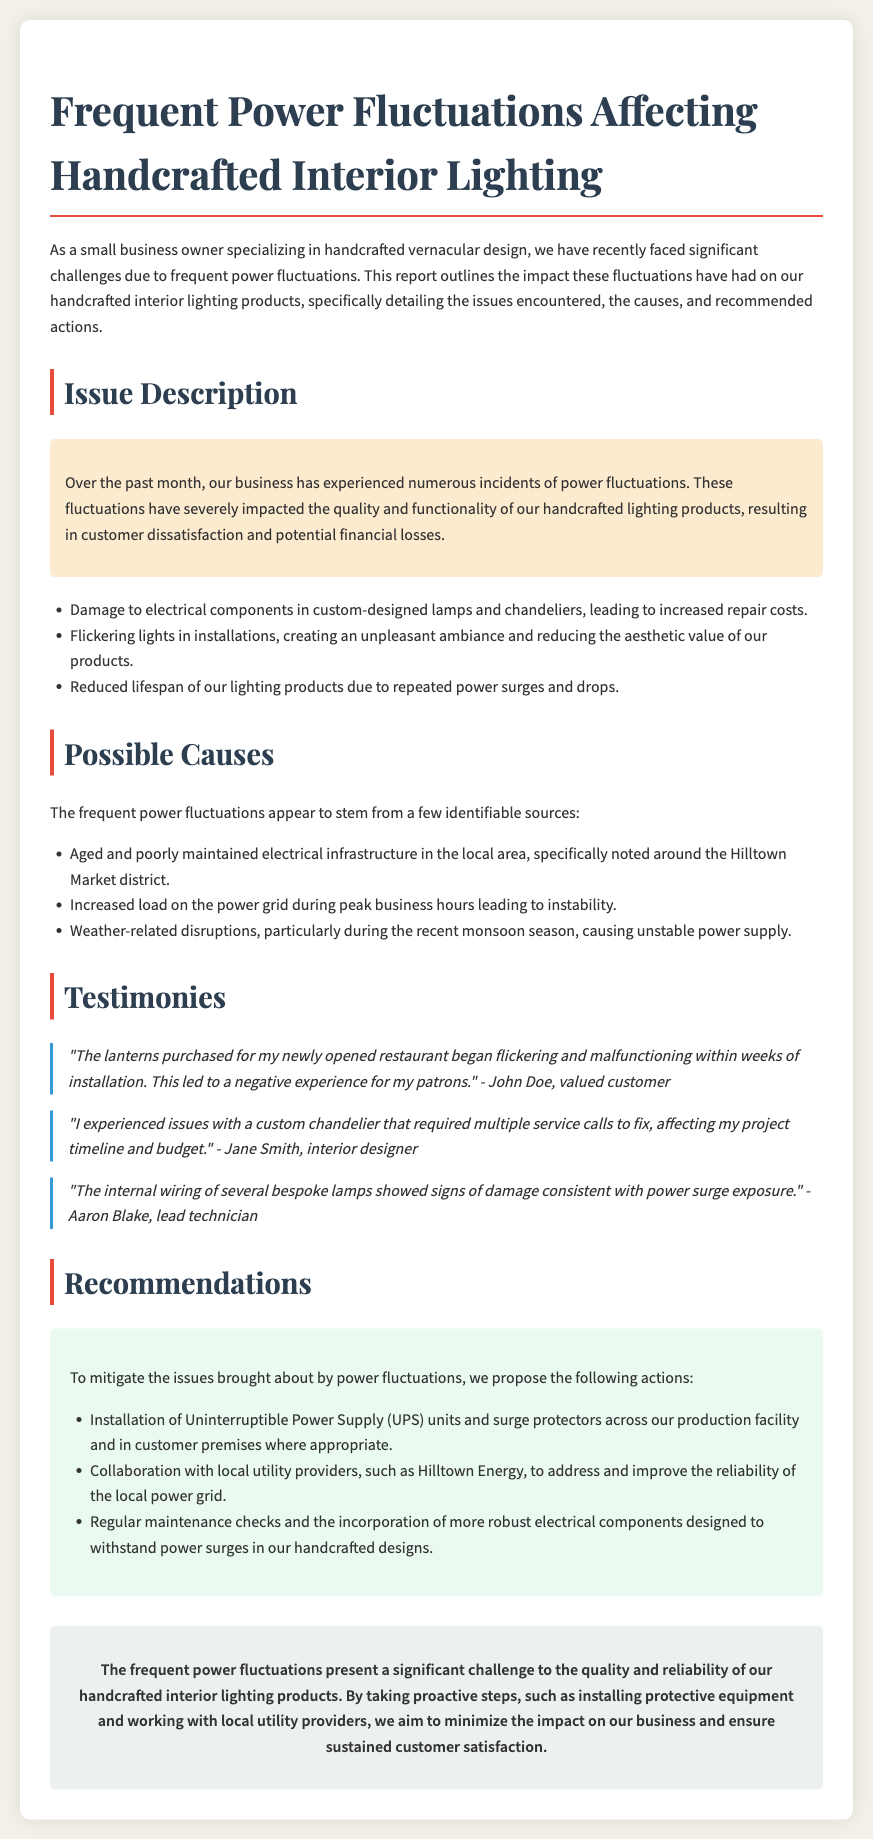What is the primary issue described in the report? The primary issue is the impact of frequent power fluctuations on handcrafted lighting products, leading to customer dissatisfaction and financial losses.
Answer: Frequent power fluctuations How many testimonies are included in the report? The report includes three testimonies from customers and a technician.
Answer: Three What specific weather-related event is mentioned as a cause of power fluctuations? The report cites the recent monsoon season as a cause of unstable power supply.
Answer: Monsoon season What company is suggested for collaboration to improve power reliability? The report mentions collaborating with Hilltown Energy to enhance the reliability of the power grid.
Answer: Hilltown Energy What is one of the recommendations given in the report? The document recommends the installation of Uninterruptible Power Supply (UPS) units and surge protectors.
Answer: Installation of UPS units and surge protectors What is the impact on the lifespan of lighting products due to power fluctuations? The report states that the lifespan of lighting products is reduced due to repeated power surges and drops.
Answer: Reduced lifespan Who reported difficulties with a custom chandelier? Jane Smith, an interior designer, reported issues with a custom chandelier that required multiple service calls.
Answer: Jane Smith What does the conclusion emphasize about the frequent power fluctuations? The conclusion emphasizes the need for proactive steps to minimize the impact on the business and sustain customer satisfaction.
Answer: Proactive steps needed to minimize impact 